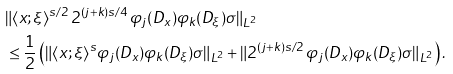<formula> <loc_0><loc_0><loc_500><loc_500>& \| \langle x ; \xi \rangle ^ { s / 2 } \, 2 ^ { ( j + k ) s / 4 } \, \varphi _ { j } ( D _ { x } ) \varphi _ { k } ( D _ { \xi } ) \sigma \| _ { L ^ { 2 } } \\ & \leq \frac { 1 } { 2 } \left ( \| \langle x ; \xi \rangle ^ { s } \varphi _ { j } ( D _ { x } ) \varphi _ { k } ( D _ { \xi } ) \sigma \| _ { L ^ { 2 } } + \| 2 ^ { ( j + k ) s / 2 } \, \varphi _ { j } ( D _ { x } ) \varphi _ { k } ( D _ { \xi } ) \sigma \| _ { L ^ { 2 } } \right ) .</formula> 